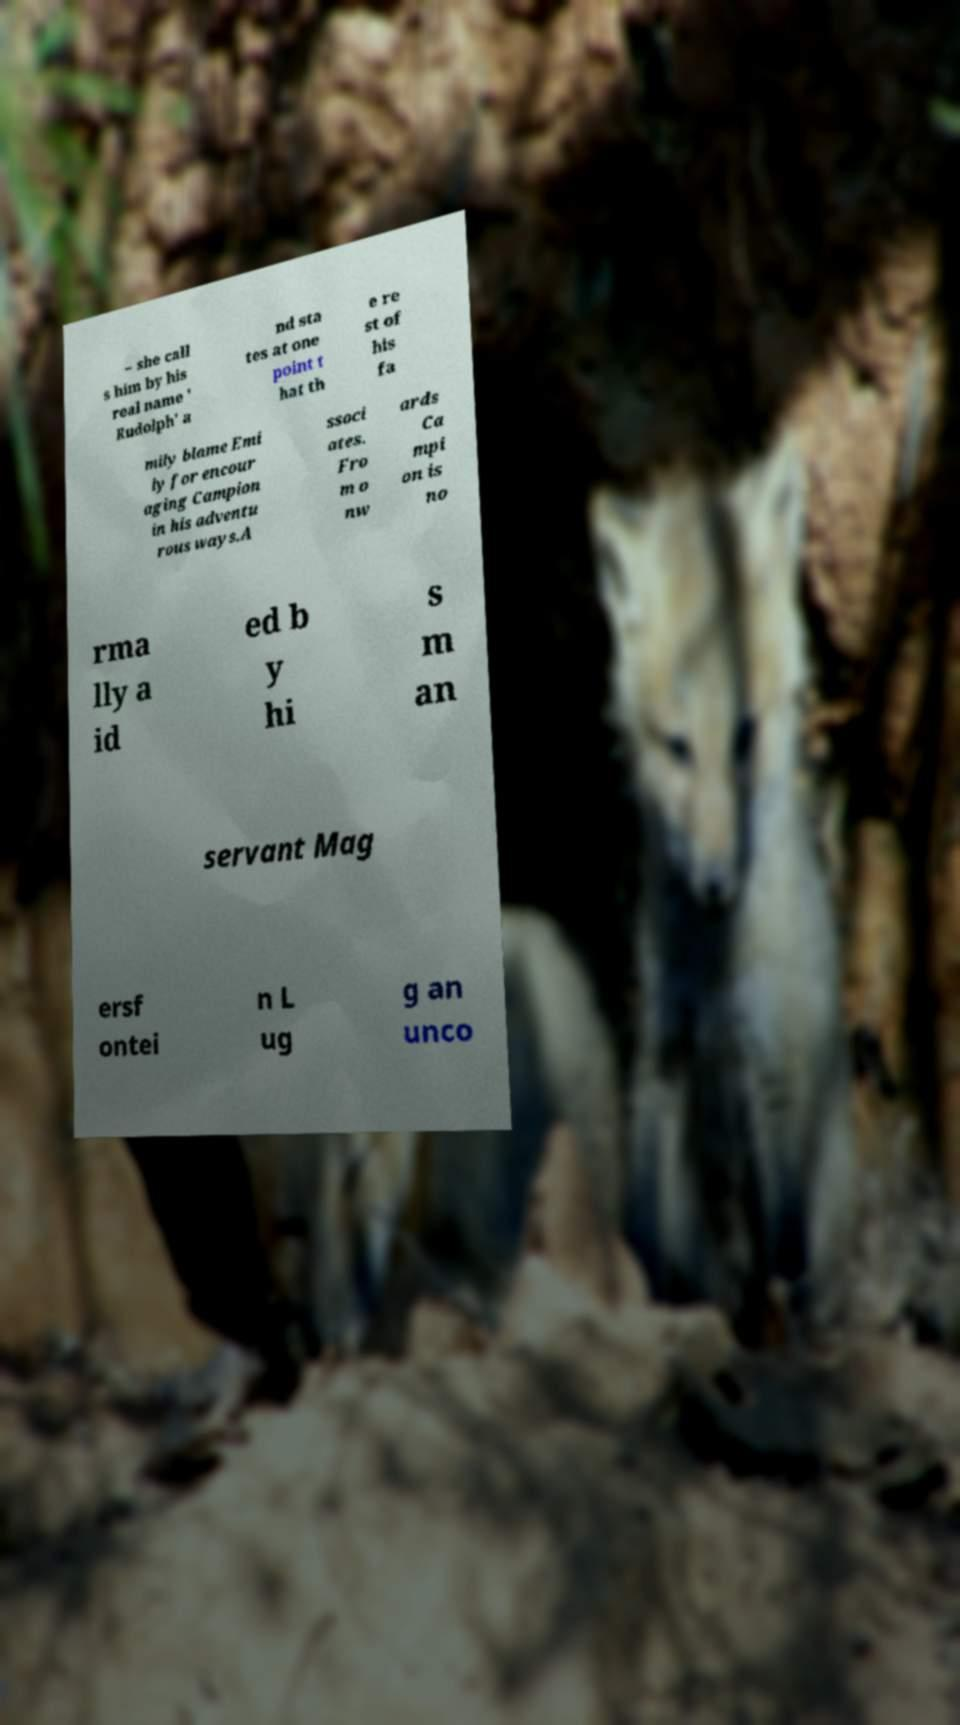What messages or text are displayed in this image? I need them in a readable, typed format. – she call s him by his real name ' Rudolph' a nd sta tes at one point t hat th e re st of his fa mily blame Emi ly for encour aging Campion in his adventu rous ways.A ssoci ates. Fro m o nw ards Ca mpi on is no rma lly a id ed b y hi s m an servant Mag ersf ontei n L ug g an unco 